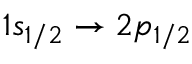Convert formula to latex. <formula><loc_0><loc_0><loc_500><loc_500>1 s _ { 1 / 2 } \rightarrow 2 p _ { 1 / 2 }</formula> 